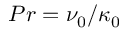Convert formula to latex. <formula><loc_0><loc_0><loc_500><loc_500>P r = \nu _ { 0 } / \kappa _ { 0 }</formula> 